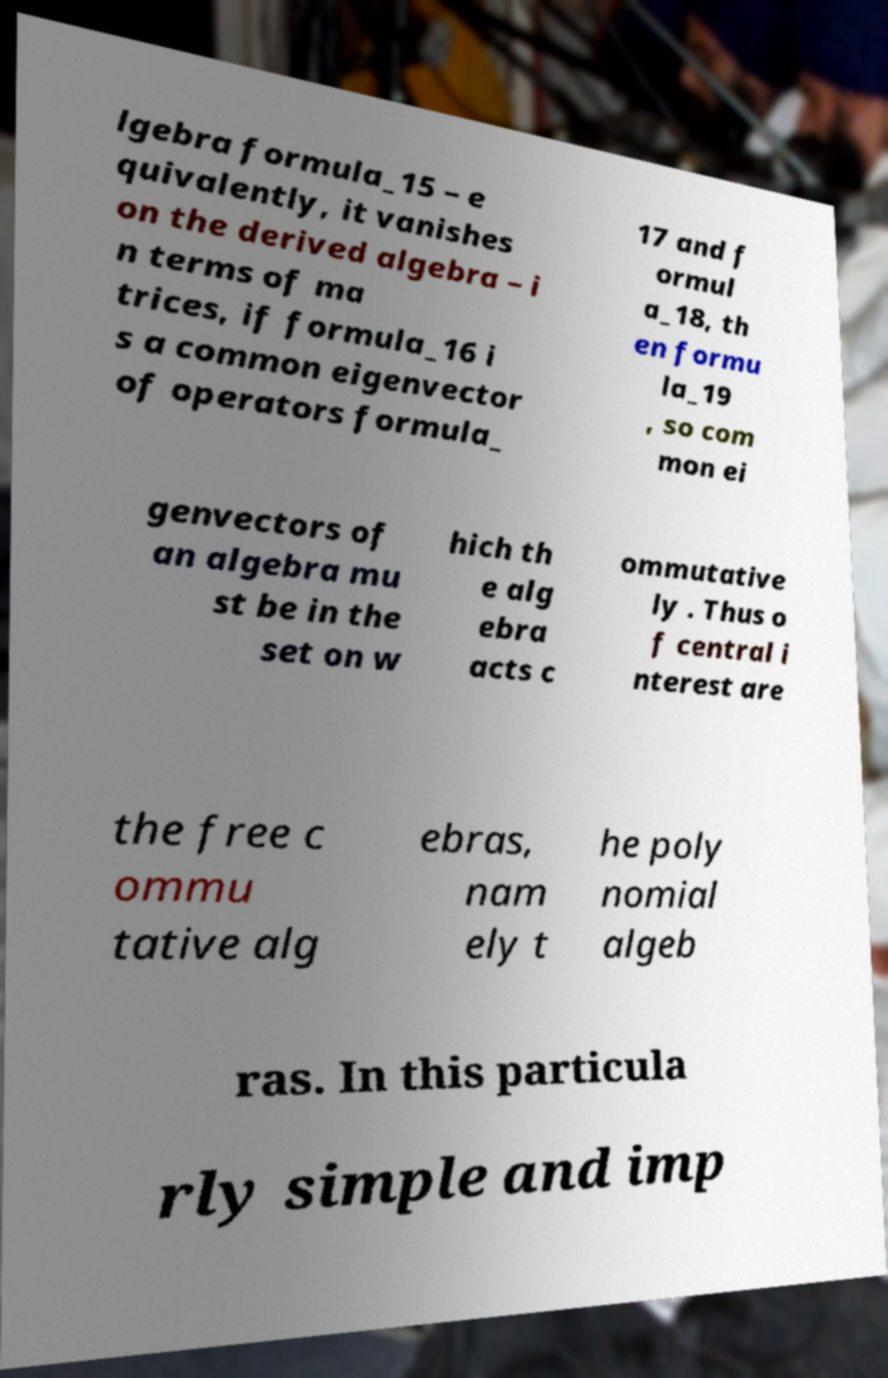Could you assist in decoding the text presented in this image and type it out clearly? lgebra formula_15 – e quivalently, it vanishes on the derived algebra – i n terms of ma trices, if formula_16 i s a common eigenvector of operators formula_ 17 and f ormul a_18, th en formu la_19 , so com mon ei genvectors of an algebra mu st be in the set on w hich th e alg ebra acts c ommutative ly . Thus o f central i nterest are the free c ommu tative alg ebras, nam ely t he poly nomial algeb ras. In this particula rly simple and imp 